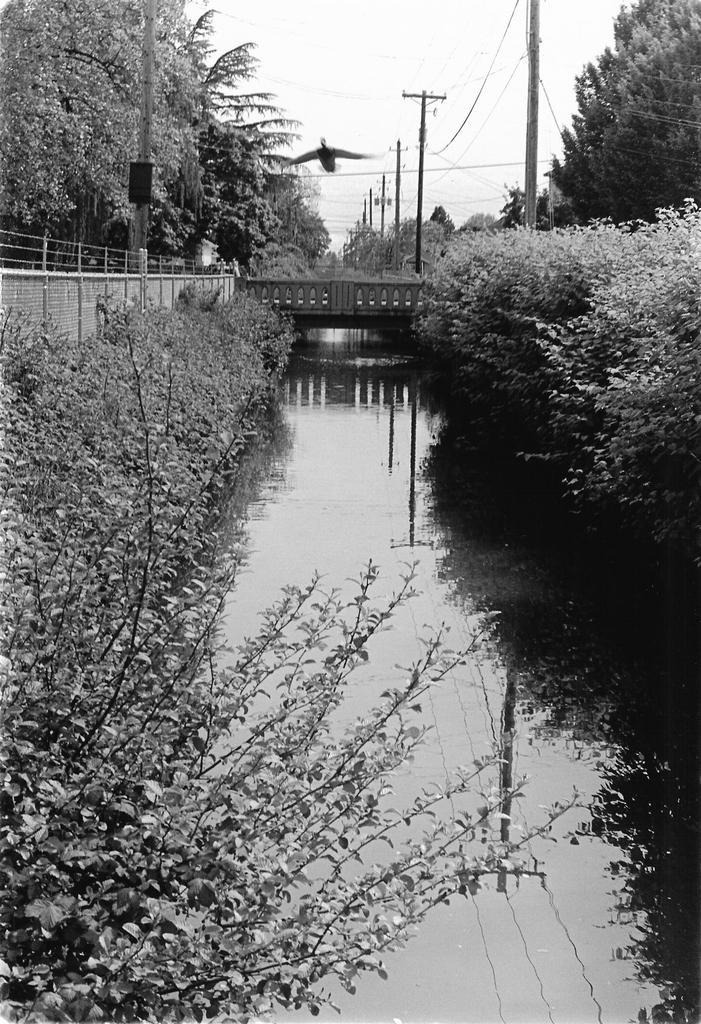How would you summarize this image in a sentence or two? This image is taken outdoors. At the bottom of the image there is a lake with water. At the top of the image there is a sky. In the middle of the image there is a bridge with a railing. On the left and right sides of the image there are many trees, plants and poles. 